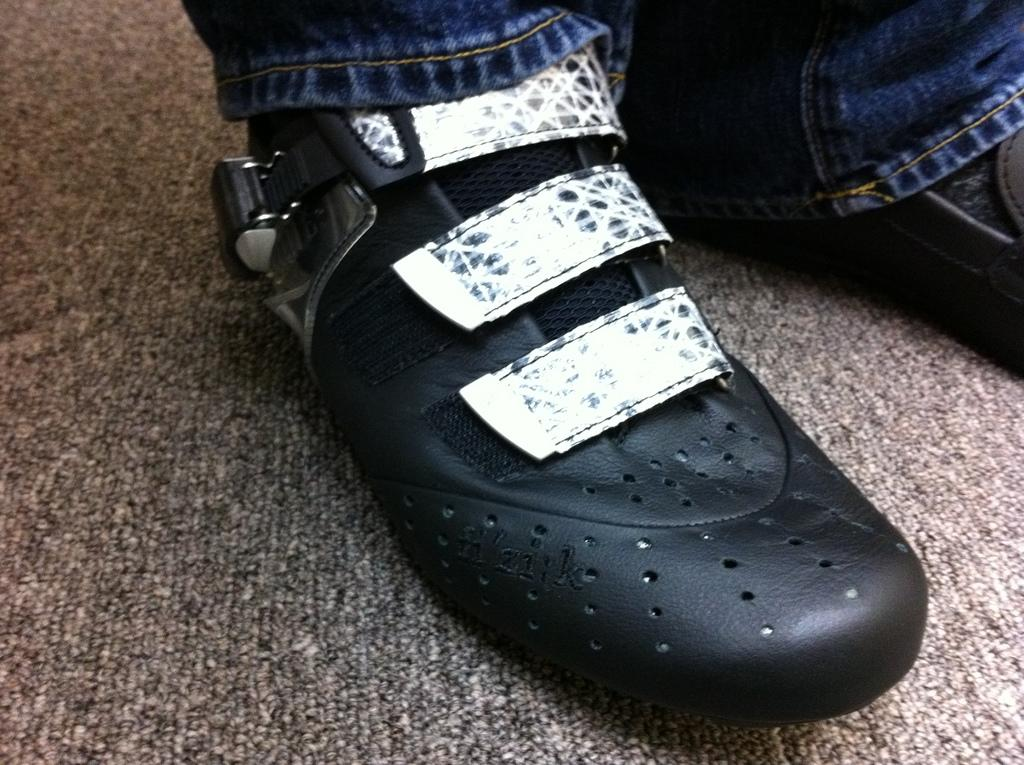What part of a person can be seen in the image? There are person's legs visible in the image. Can you describe the setting where the legs are located? The image is taken in a room. What type of journey is the person embarking on in the image? There is no indication of a journey in the image; it only shows a person's legs in a room. What language is the person speaking in the image? There is no indication of speech or language in the image; it only shows a person's legs in a room. 